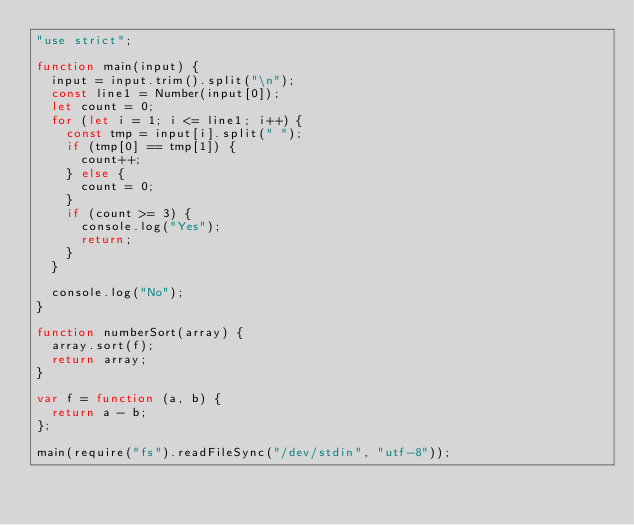<code> <loc_0><loc_0><loc_500><loc_500><_JavaScript_>"use strict";

function main(input) {
  input = input.trim().split("\n");
  const line1 = Number(input[0]);
  let count = 0;
  for (let i = 1; i <= line1; i++) {
    const tmp = input[i].split(" ");
    if (tmp[0] == tmp[1]) {
      count++;
    } else {
      count = 0;
    }
    if (count >= 3) {
      console.log("Yes");
      return;
    }
  }

  console.log("No");
}

function numberSort(array) {
  array.sort(f);
  return array;
}

var f = function (a, b) {
  return a - b;
};

main(require("fs").readFileSync("/dev/stdin", "utf-8"));
</code> 